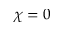Convert formula to latex. <formula><loc_0><loc_0><loc_500><loc_500>\chi = 0</formula> 